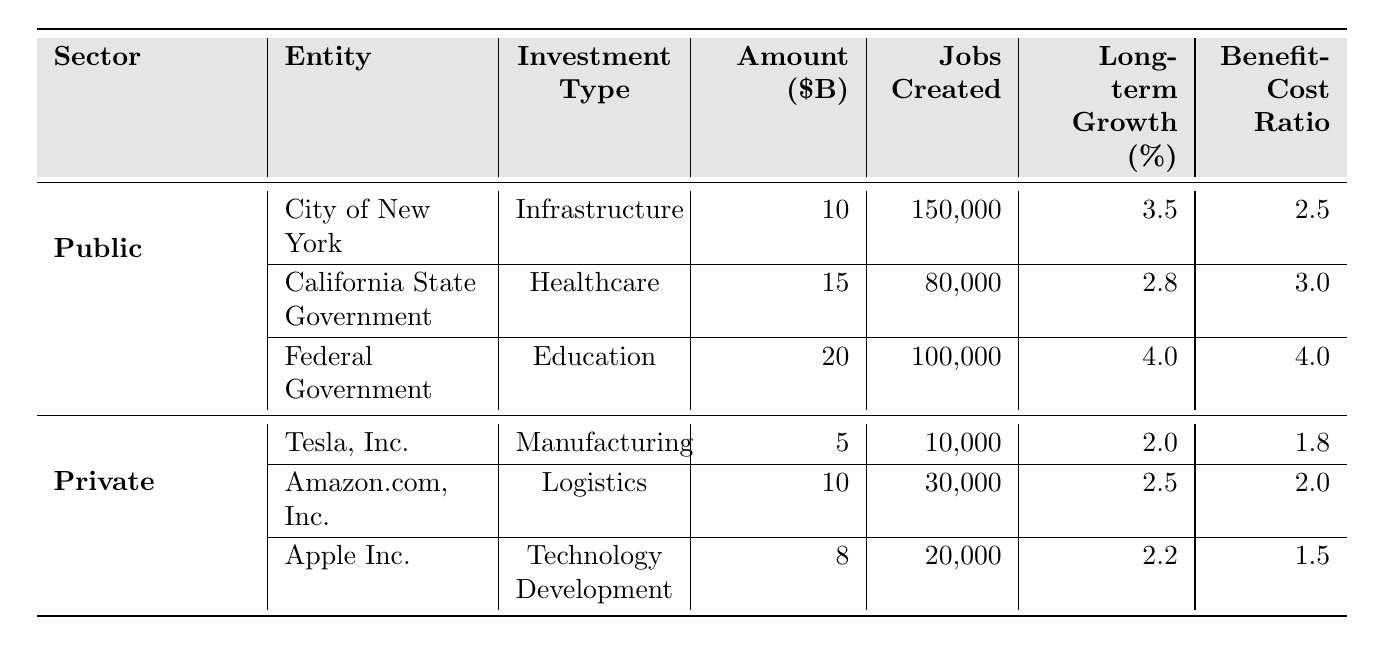What is the total amount of investment from the public sector? To find this, we sum the investments for the public sector: $10 billion (City of New York) + $15 billion (California State Government) + $20 billion (Federal Government) = $45 billion.
Answer: $45 billion Which public sector investment created the most jobs? The jobs created by each public sector investment are: 150,000 (City of New York), 80,000 (California State Government), and 100,000 (Federal Government). The highest number is 150,000 jobs from the City of New York.
Answer: City of New York What is the average long-term economic growth percentage for public sector investments? The long-term growth percentages for public sector investments are: 3.5%, 2.8%, and 4.0%. Adding these gives 10.3%, and dividing by 3 gives an average of 10.3% / 3 = 3.43%.
Answer: 3.43% True or False: The benefit-cost ratio for the Federal Government's investment is the highest among all entities. The benefit-cost ratios are 2.5 (City of New York), 3.0 (California State Government), 4.0 (Federal Government), 1.8 (Tesla), 2.0 (Amazon), and 1.5 (Apple). The highest is indeed 4.0 for the Federal Government.
Answer: True Which sector, public or private, has a better average benefit-cost ratio? For public sector: average is (2.5 + 3.0 + 4.0) = 9.5, divided by 3 equals 3.17. For private: (1.8 + 2.0 + 1.5) = 5.3, divided by 3 equals 1.77. Comparing averages, 3.17 (public) > 1.77 (private).
Answer: Public sector What is the total job creation from private sector investments? The jobs created by private sector investments are: 10,000 (Tesla) + 30,000 (Amazon) + 20,000 (Apple) = 60,000.
Answer: 60,000 Which investment has the lowest amount but still creates a notable number of jobs? Tesla's investment is the lowest at $5 billion but creates 10,000 jobs, which is notable considering the low investment amount compared to others.
Answer: Tesla, Inc If we compare the benefit-cost ratios, which public sector investment is less effective than Amazon's private sector investment? The benefit-cost ratio for Amazon is 2.0. The City of New York (2.5) and California (3.0) both have higher ratios, while Tesla (1.8) and Apple (1.5) are lower than Amazon. Thus, California's investment is less effective than Amazon’s.
Answer: California State Government What is the combined economic growth percentage from all private sector investments? Sum the long-term growth percentages for the private sector: 2.0 (Tesla) + 2.5 (Amazon) + 2.2 (Apple) = 6.7%.
Answer: 6.7% How many more jobs were created by public sector investments compared to private sector investments? Public sector created 150,000 + 80,000 + 100,000 = 330,000 jobs; private sector created 10,000 + 30,000 + 20,000 = 60,000 jobs. The difference is 330,000 - 60,000 = 270,000.
Answer: 270,000 